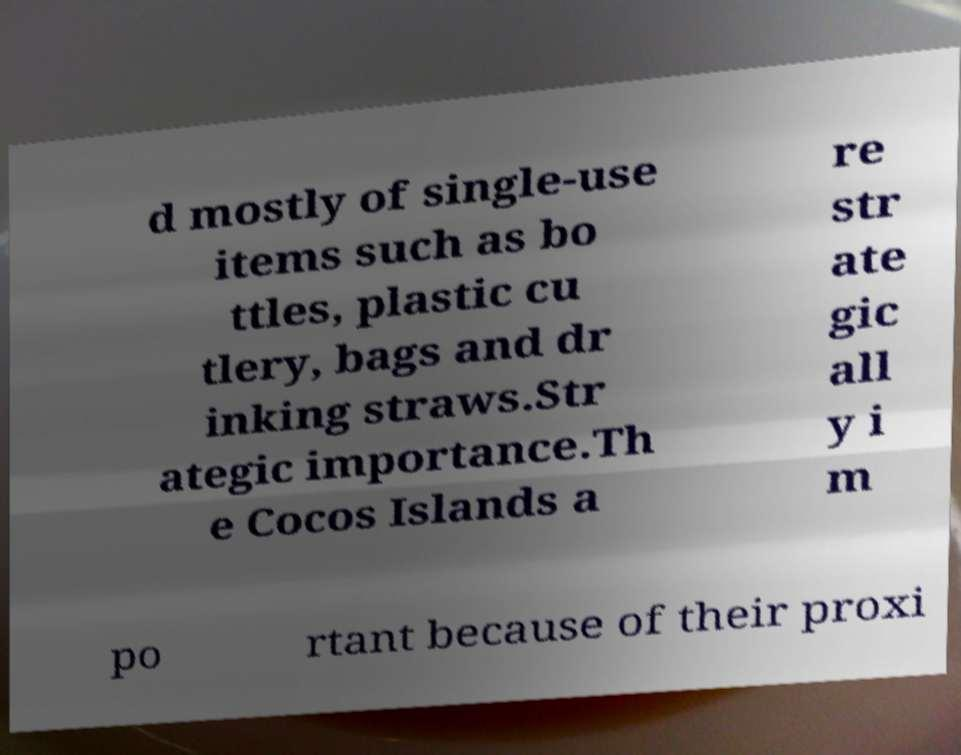Could you assist in decoding the text presented in this image and type it out clearly? d mostly of single-use items such as bo ttles, plastic cu tlery, bags and dr inking straws.Str ategic importance.Th e Cocos Islands a re str ate gic all y i m po rtant because of their proxi 